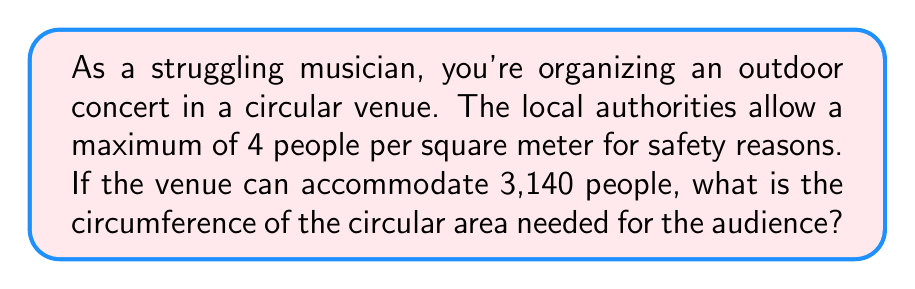Show me your answer to this math problem. Let's approach this step-by-step:

1) First, we need to find the area of the circular venue:
   - Given: 4 people per square meter
   - Total people: 3,140
   - Area = $\frac{3,140 \text{ people}}{4 \text{ people/m}^2} = 785 \text{ m}^2$

2) Now that we have the area, we can use the formula for the area of a circle to find the radius:
   $A = \pi r^2$
   $785 = \pi r^2$

3) Solving for $r$:
   $r^2 = \frac{785}{\pi}$
   $r = \sqrt{\frac{785}{\pi}} \approx 15.8 \text{ m}$

4) Now that we have the radius, we can use the formula for the circumference of a circle:
   $C = 2\pi r$

5) Plugging in our value for $r$:
   $C = 2\pi(15.8) \approx 99.3 \text{ m}$

[asy]
unitsize(1cm);
real r = 1.58;
draw(circle((0,0), r));
draw((0,0)--(r,0), arrow=Arrow(TeXHead));
label("15.8 m", (r/2,0), S);
label("C ≈ 99.3 m", (0,0), N);
[/asy]
Answer: $99.3 \text{ m}$ 